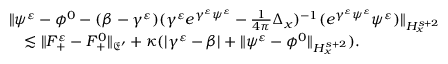<formula> <loc_0><loc_0><loc_500><loc_500>\begin{array} { r } { \begin{array} { r l } & { \| \psi ^ { \varepsilon } - \phi ^ { 0 } - ( \beta - \gamma ^ { \varepsilon } ) ( \gamma ^ { \varepsilon } e ^ { \gamma ^ { \varepsilon } \psi ^ { \varepsilon } } - \frac { 1 } { 4 \pi } \Delta _ { x } ) ^ { - 1 } ( e ^ { \gamma ^ { \varepsilon } \psi ^ { \varepsilon } } \psi ^ { \varepsilon } ) \| _ { H _ { x } ^ { s + 2 } } } \\ & { \quad \lesssim \| F _ { + } ^ { \varepsilon } - F _ { + } ^ { 0 } \| _ { \mathfrak E ^ { \prime } } + \kappa ( | \gamma ^ { \varepsilon } - \beta | + \| \psi ^ { \varepsilon } - \phi ^ { 0 } \| _ { H _ { x } ^ { s + 2 } } ) . } \end{array} } \end{array}</formula> 